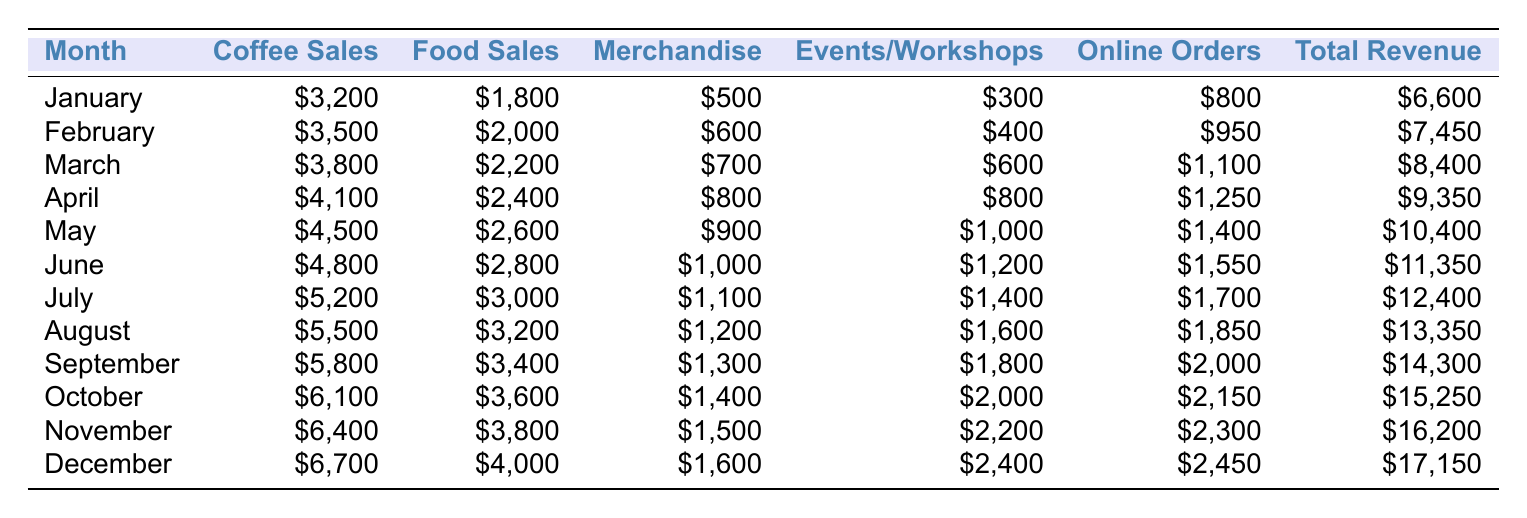What is the total revenue in December? The table shows that the total revenue for December is \$17,150.
Answer: \$17,150 In which month did the coffee shop make the highest merchandise sales? Looking at the merchandise sales column, December shows the highest value at \$1,600.
Answer: December What is the average food sales over the year? To find the average food sales, sum all food sales from January to December (1,800 + 2,000 + 2,200 + 2,400 + 2,600 + 2,800 + 3,000 + 3,200 + 3,400 + 3,600 + 3,800 + 4,000 = 33,000) and divide by 12, which gives an average of \$2,750.
Answer: \$2,750 How much more revenue was generated in October compared to January? In October, the total revenue was \$15,250, and in January, it was \$6,600. The difference is \$15,250 - \$6,600 = \$8,650.
Answer: \$8,650 Which month had the least online orders and how many were they? By looking at the online orders column, January had the least number of online orders at \$800.
Answer: January, \$800 What percentage of total revenue in July came from coffee sales? In July, the total revenue was \$12,400, with \$5,200 from coffee sales. The percentage is calculated as (5,200 / 12,400) * 100 = 41.94%.
Answer: 41.94% Can you identify the month with the highest combined revenue from merchandise and events/workshops? Adding merchandise and events/workshops collectively: January (500 + 300), February (600 + 400), March (700 + 600), and so on. December (1,600 + 2,400 = 4,000) is the highest among the months.
Answer: December What is the total revenue for the first half of the year (January to June)? The total revenue for the first half of the year can be calculated by summing the revenues for these months: January (6,600), February (7,450), March (8,400), April (9,350), May (10,400), and June (11,350). The total is \$53,450.
Answer: \$53,450 Did the coffee shop experience an increase in total revenue every month? The total revenue increased each month from January through December, as shown by the consecutive increases in the total revenue values.
Answer: Yes What was the difference in food sales between the highest and lowest months? The highest food sales occurred in December at \$4,000, while the lowest occurred in January at \$1,800. The difference is \$4,000 - \$1,800 = \$2,200.
Answer: \$2,200 